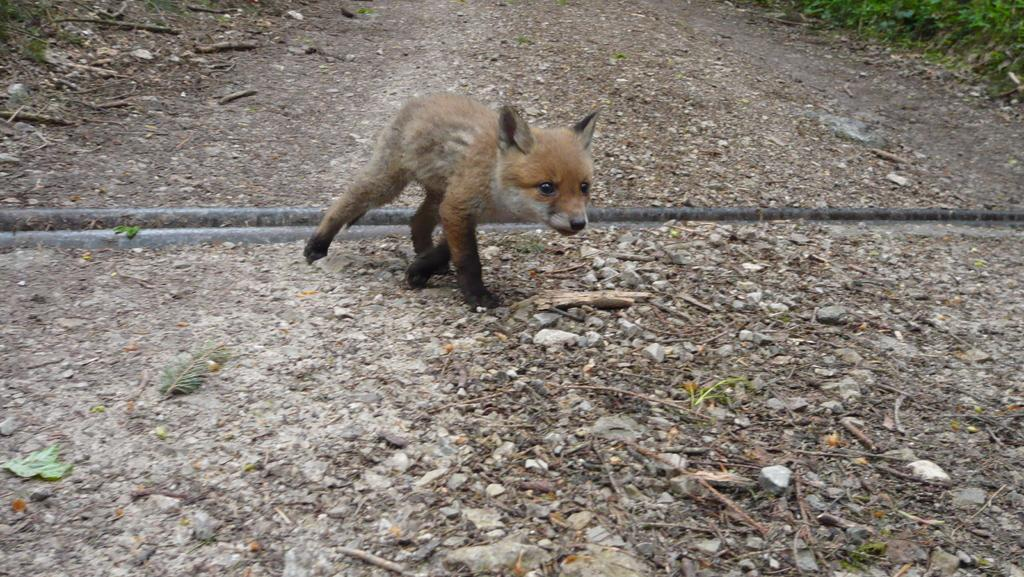What type of animal is in the image? There is a baby fox in the image. What is the baby fox doing in the image? The baby fox is walking on the land. Can you describe the terrain in the image? The land contains stones and dry twigs. What can be seen on the right side of the image? There are planets visible on the right side of the image. What type of structure is the baby fox using to process the hook? There is no structure, process, or hook present in the image; it features a baby fox walking on the land with visible planets in the background. 